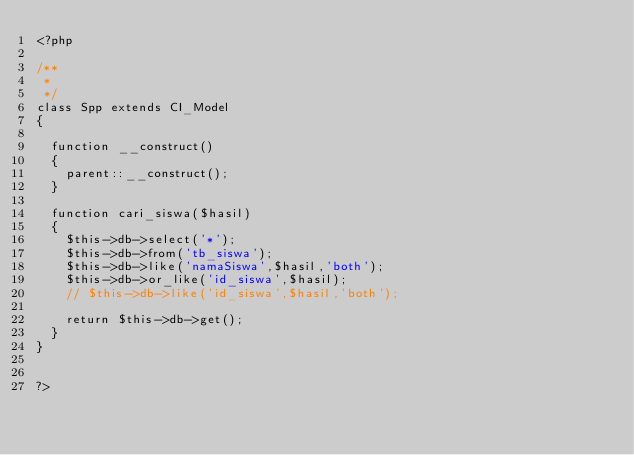Convert code to text. <code><loc_0><loc_0><loc_500><loc_500><_PHP_><?php

/**
 *
 */
class Spp extends CI_Model
{

  function __construct()
  {
    parent::__construct();
  }

  function cari_siswa($hasil)
  {
    $this->db->select('*');
    $this->db->from('tb_siswa');
    $this->db->like('namaSiswa',$hasil,'both');
    $this->db->or_like('id_siswa',$hasil);
    // $this->db->like('id_siswa',$hasil,'both');

    return $this->db->get();
  }
}


?>
</code> 